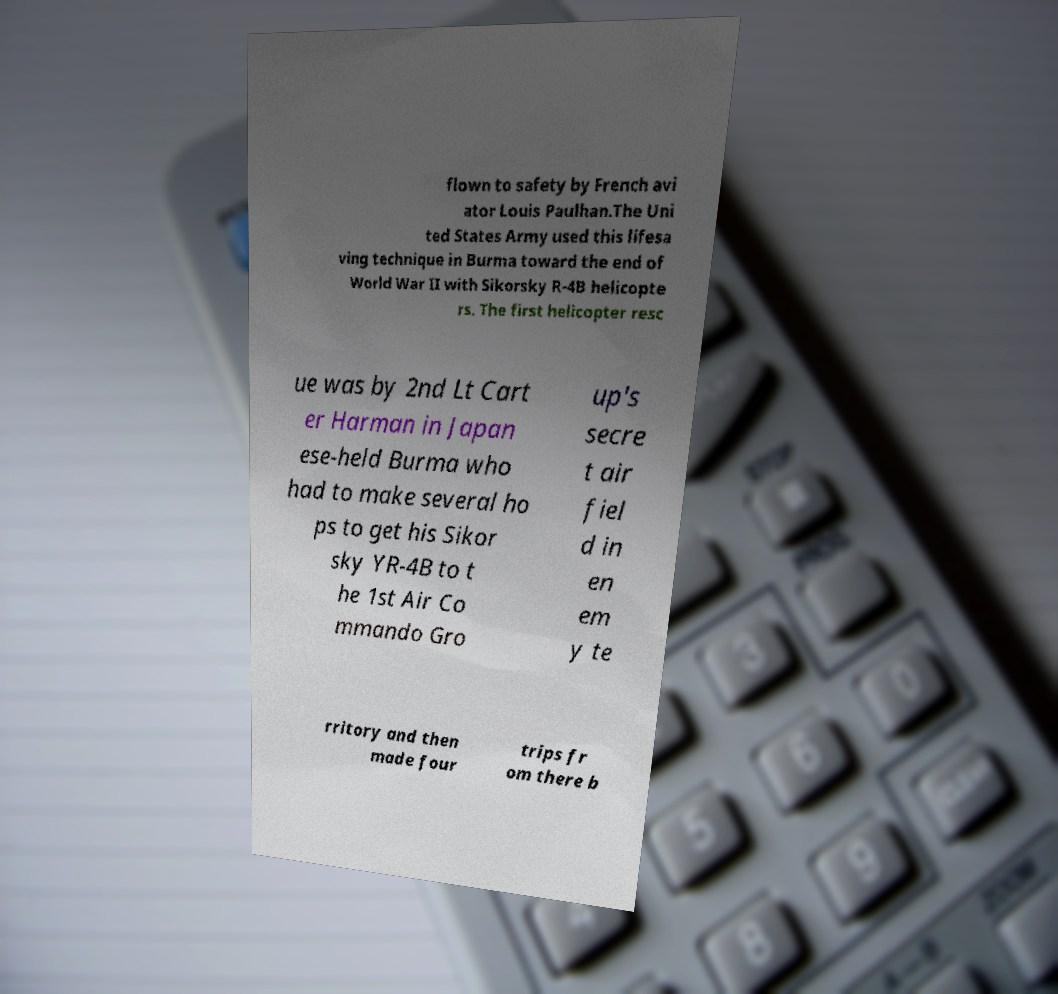Please read and relay the text visible in this image. What does it say? flown to safety by French avi ator Louis Paulhan.The Uni ted States Army used this lifesa ving technique in Burma toward the end of World War II with Sikorsky R-4B helicopte rs. The first helicopter resc ue was by 2nd Lt Cart er Harman in Japan ese-held Burma who had to make several ho ps to get his Sikor sky YR-4B to t he 1st Air Co mmando Gro up's secre t air fiel d in en em y te rritory and then made four trips fr om there b 